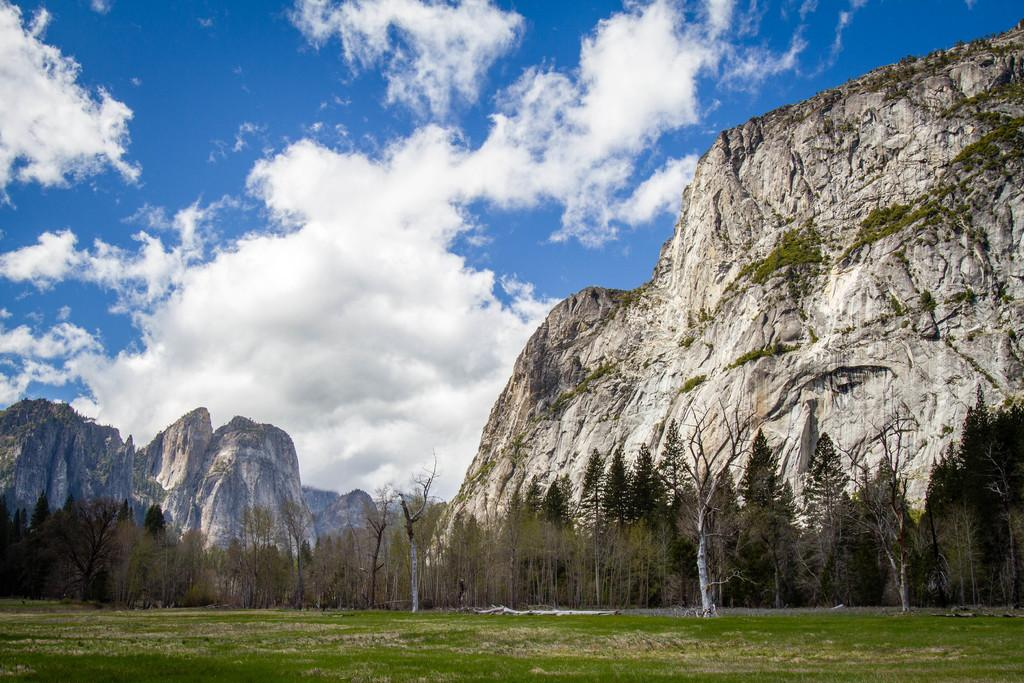What type of vegetation can be seen in the image? There is grass in the image. What other natural elements are present in the image? There are trees and hills visible in the image. What is visible in the sky in the image? There are clouds visible in the image. What type of loaf can be seen hanging from the trees in the image? There is no loaf present in the image; it features grass, trees, hills, and clouds. How many branches are visible on the fowl in the image? There is no fowl present in the image; it only contains grass, trees, hills, and clouds. 